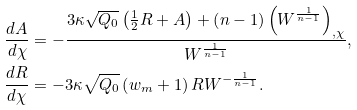<formula> <loc_0><loc_0><loc_500><loc_500>\frac { d A } { d \chi } & = - \frac { 3 \kappa \sqrt { Q _ { 0 } } \left ( \frac { 1 } { 2 } R + A \right ) + \left ( n - 1 \right ) \left ( W ^ { \frac { 1 } { n - 1 } } \right ) _ { , \chi } } { W ^ { \frac { 1 } { n - 1 } } } , \\ \frac { d R } { d \chi } & = - 3 \kappa \sqrt { Q _ { 0 } } \left ( w _ { m } + 1 \right ) R W ^ { - \frac { 1 } { n - 1 } } .</formula> 